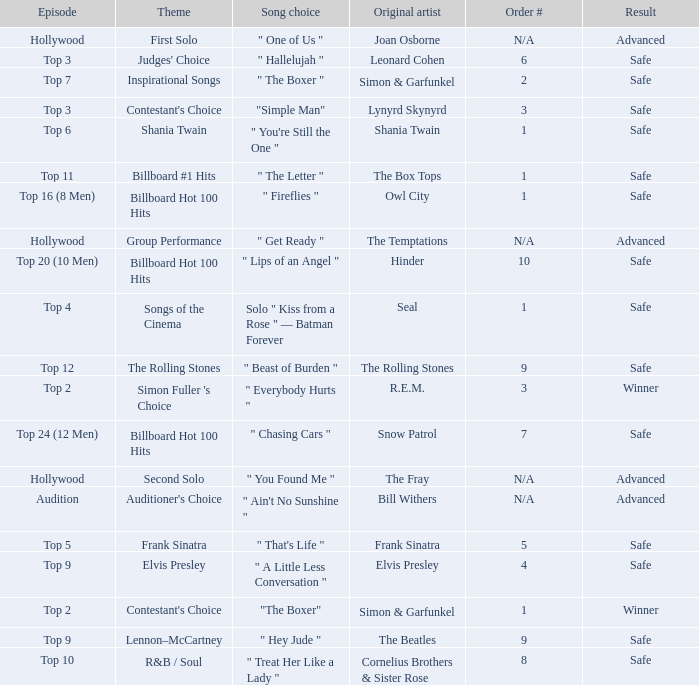In which episode is the order number 10? Top 20 (10 Men). 